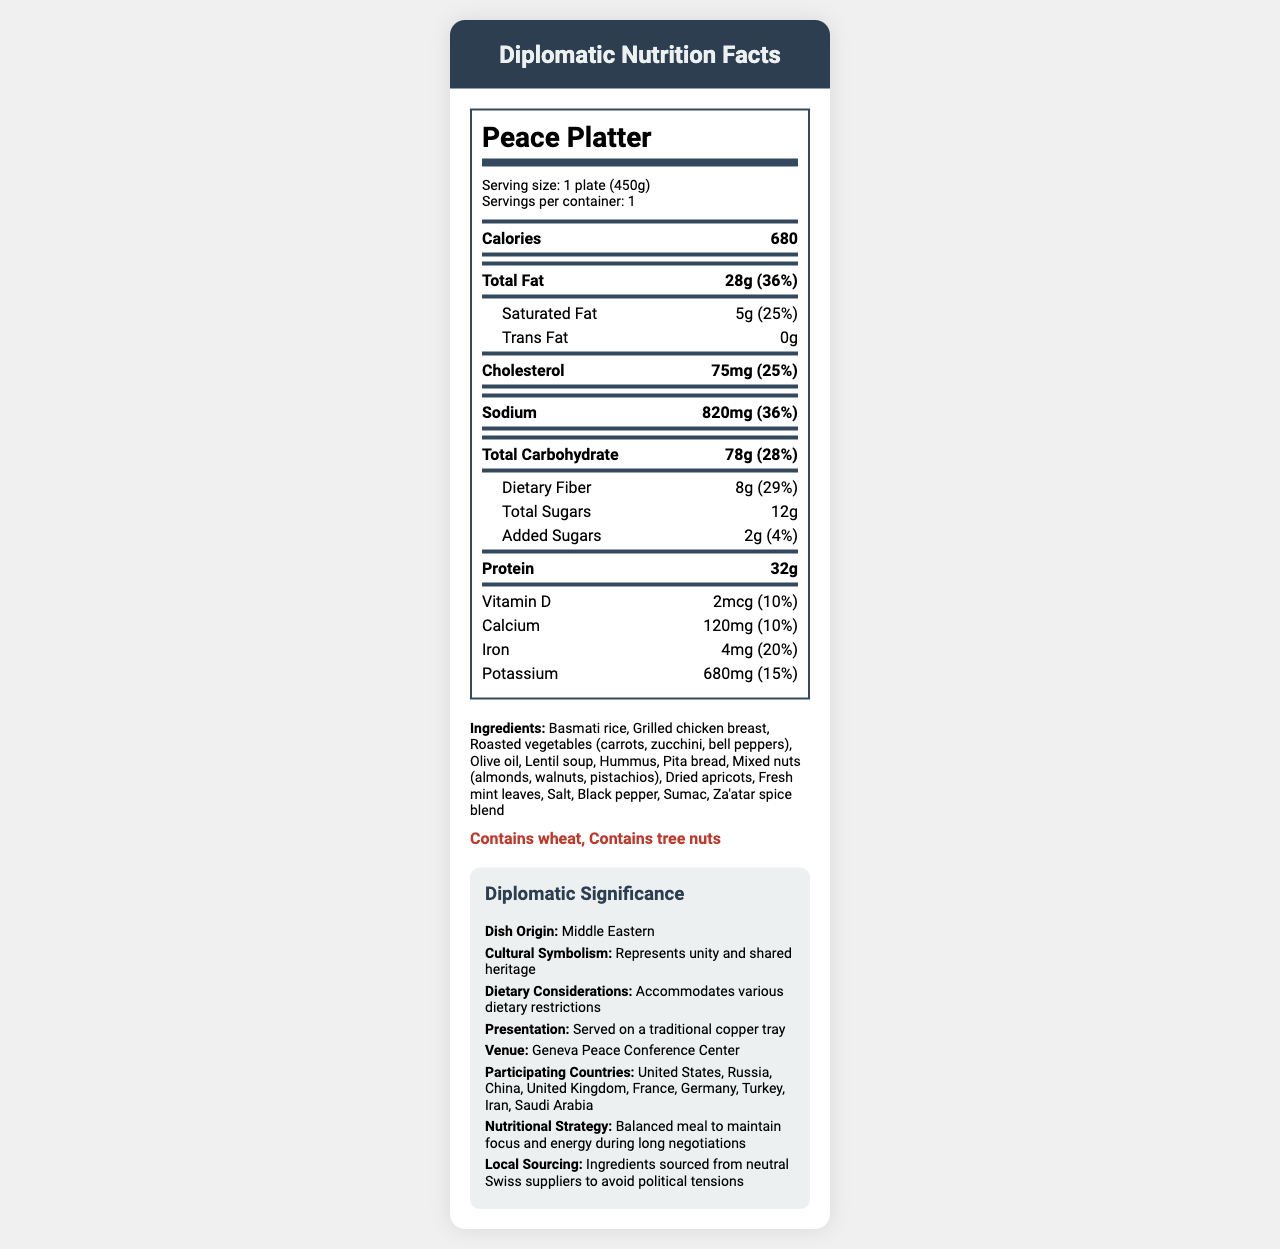what is the serving size of the Peace Platter? The serving size is explicitly mentioned as "1 plate (450g)" in the document.
Answer: 1 plate (450g) how many calories does one Peace Platter contain? The document lists the calorie count per Peace Platter as 680.
Answer: 680 what is the total fat content in grams? The total fat is listed as 28 grams in the nutrition facts section.
Answer: 28g what is the percentage daily value for sodium? The percentage daily value for sodium is mentioned as 36%.
Answer: 36% what are the main ingredients in the Peace Platter? The main ingredients are listed in the ingredients section.
Answer: Basmati rice, Grilled chicken breast, Roasted vegetables, Olive oil, Lentil soup, Hummus, Pita bread, Mixed nuts, Dried apricots, Fresh mint leaves, Salt, Black pepper, Sumac, Za'atar spice blend what is the amount of dietary fiber per serving? Dietary fiber is listed as 8 grams per serving.
Answer: 8g what is the cultural symbolism of the dish? The document states that the Peace Platter represents unity and shared heritage.
Answer: Represents unity and shared heritage which participating country is not part of NATO? A. United States B. Germany C. Iran D. United Kingdom Iran is not a member of NATO, whereas the United States, Germany, and the United Kingdom are.
Answer: C what is the venue for the negotiations? The venue for the negotiations is mentioned as the Geneva Peace Conference Center.
Answer: Geneva Peace Conference Center which nutrient is provided in the smallest amount by percentage of daily value? A. Calcium B. Vitamin D C. Iron D. Potassium Vitamin D at 10% daily value is provided in the smallest amount in comparison to Calcium (10%), Iron (20%), and Potassium (15%).
Answer: B does the Peace Platter contain trans fat? The document lists the trans fat content as 0 grams, which indicates there is no trans fat.
Answer: No summarize the main idea of the document. The main idea of the document is to present the nutritional and cultural details of the Peace Platter served during high-stakes diplomatic negotiations, along with its significance and strategic choices.
Answer: The document details the nutritional facts, ingredients, cultural significance, and context for the Peace Platter, a traditional Middle Eastern dish served during diplomatic negotiations at the Geneva Peace Conference Center. The meal is crafted to be balanced, accommodating various dietary restrictions and sourced from neutral suppliers to avoid political tensions. what are the health benefits of the Peace Platter? The document provides the nutritional content but does not offer specific health benefits.
Answer: Cannot be determined 